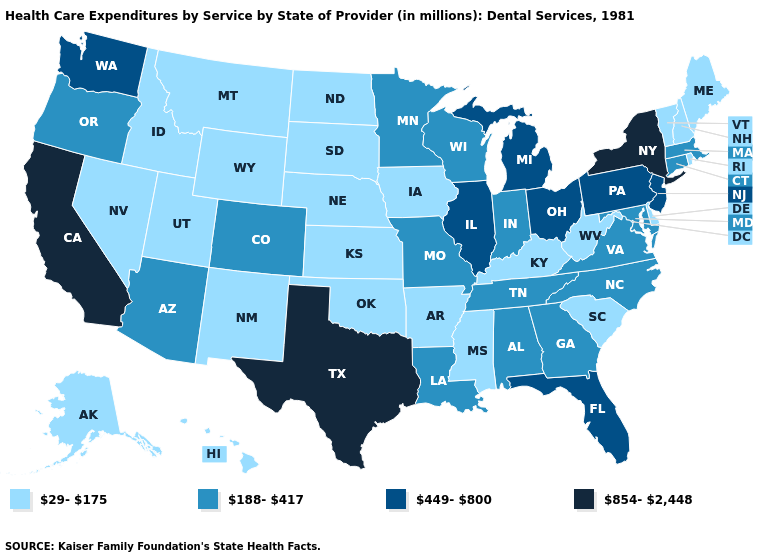What is the value of Florida?
Quick response, please. 449-800. What is the value of Utah?
Short answer required. 29-175. Name the states that have a value in the range 854-2,448?
Keep it brief. California, New York, Texas. What is the highest value in the South ?
Concise answer only. 854-2,448. What is the value of Louisiana?
Short answer required. 188-417. Does Oklahoma have the same value as Kansas?
Quick response, please. Yes. Which states hav the highest value in the West?
Short answer required. California. Does Kentucky have the lowest value in the South?
Concise answer only. Yes. Among the states that border Maryland , does Pennsylvania have the highest value?
Concise answer only. Yes. Name the states that have a value in the range 29-175?
Write a very short answer. Alaska, Arkansas, Delaware, Hawaii, Idaho, Iowa, Kansas, Kentucky, Maine, Mississippi, Montana, Nebraska, Nevada, New Hampshire, New Mexico, North Dakota, Oklahoma, Rhode Island, South Carolina, South Dakota, Utah, Vermont, West Virginia, Wyoming. Which states have the lowest value in the MidWest?
Short answer required. Iowa, Kansas, Nebraska, North Dakota, South Dakota. What is the lowest value in the MidWest?
Quick response, please. 29-175. Does Hawaii have a lower value than New Hampshire?
Keep it brief. No. Does Michigan have the same value as Florida?
Answer briefly. Yes. What is the highest value in the USA?
Quick response, please. 854-2,448. 